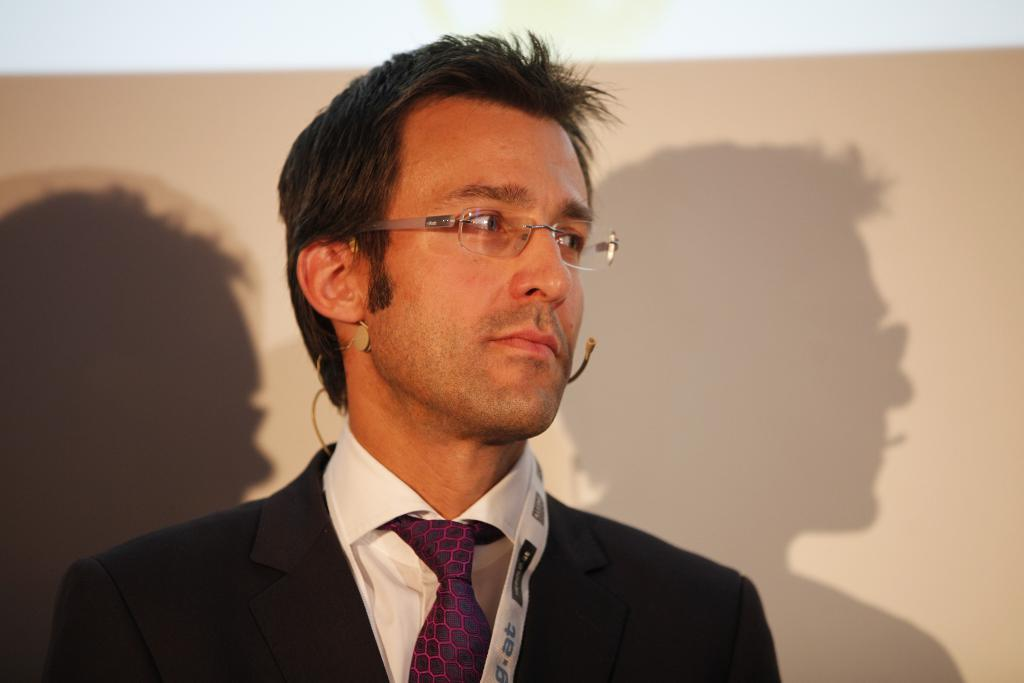Who is present in the image? There is a man in the image. What is the man wearing on his face? The man is wearing glasses (specs) in the image. What is the man wearing on his upper body? The man is wearing a white shirt, a tie, and a black blazer in the image. What object is visible in the image that is commonly used for amplifying sound? There is a microphone (mic) in the image. What can be observed in the background of the image? There are shadows visible in the background of the image. Can you see any snakes on the island in the image? There is no island or snake present in the image. What type of farm animals can be seen grazing in the background of the image? There are no farm animals or any indication of a farm in the image. 